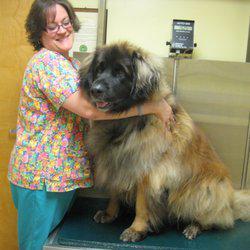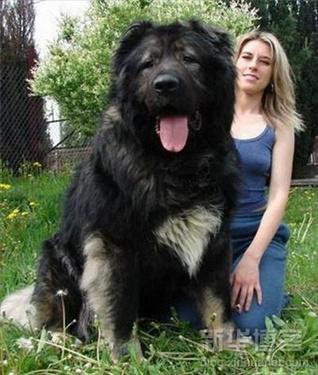The first image is the image on the left, the second image is the image on the right. Considering the images on both sides, is "Two large dogs have black faces and their mouths open." valid? Answer yes or no. Yes. The first image is the image on the left, the second image is the image on the right. For the images displayed, is the sentence "There is a woman with a large dog in the image on the left" factually correct? Answer yes or no. Yes. 